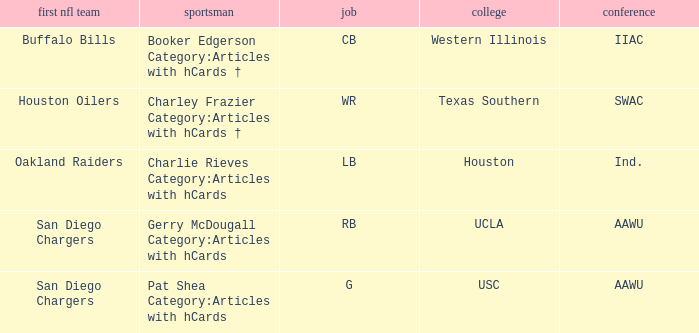What player's original team are the Oakland Raiders? Charlie Rieves Category:Articles with hCards. 